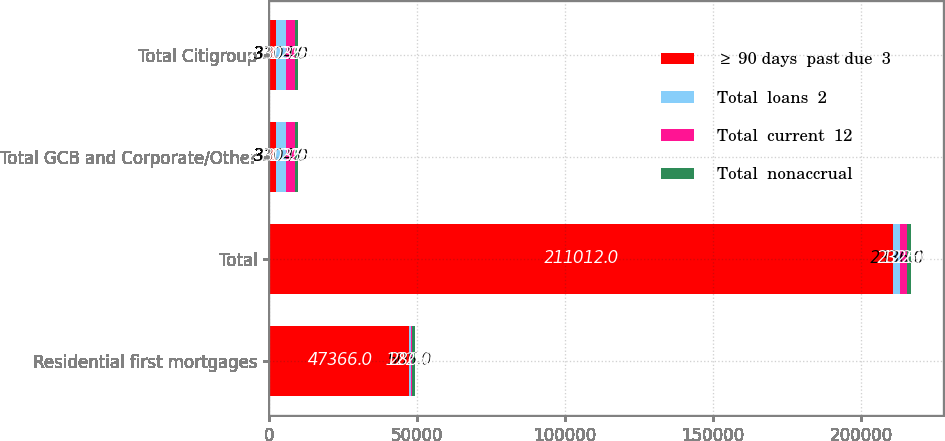Convert chart. <chart><loc_0><loc_0><loc_500><loc_500><stacked_bar_chart><ecel><fcel>Residential first mortgages<fcel>Total<fcel>Total GCB and Corporate/Other<fcel>Total Citigroup<nl><fcel>≥ 90 days  past due  3<fcel>47366<fcel>211012<fcel>2331<fcel>2331<nl><fcel>Total  loans  2<fcel>505<fcel>2336<fcel>3304<fcel>3304<nl><fcel>Total  current  12<fcel>280<fcel>2326<fcel>3035<fcel>3035<nl><fcel>Total  nonaccrual<fcel>1225<fcel>1225<fcel>1225<fcel>1225<nl></chart> 